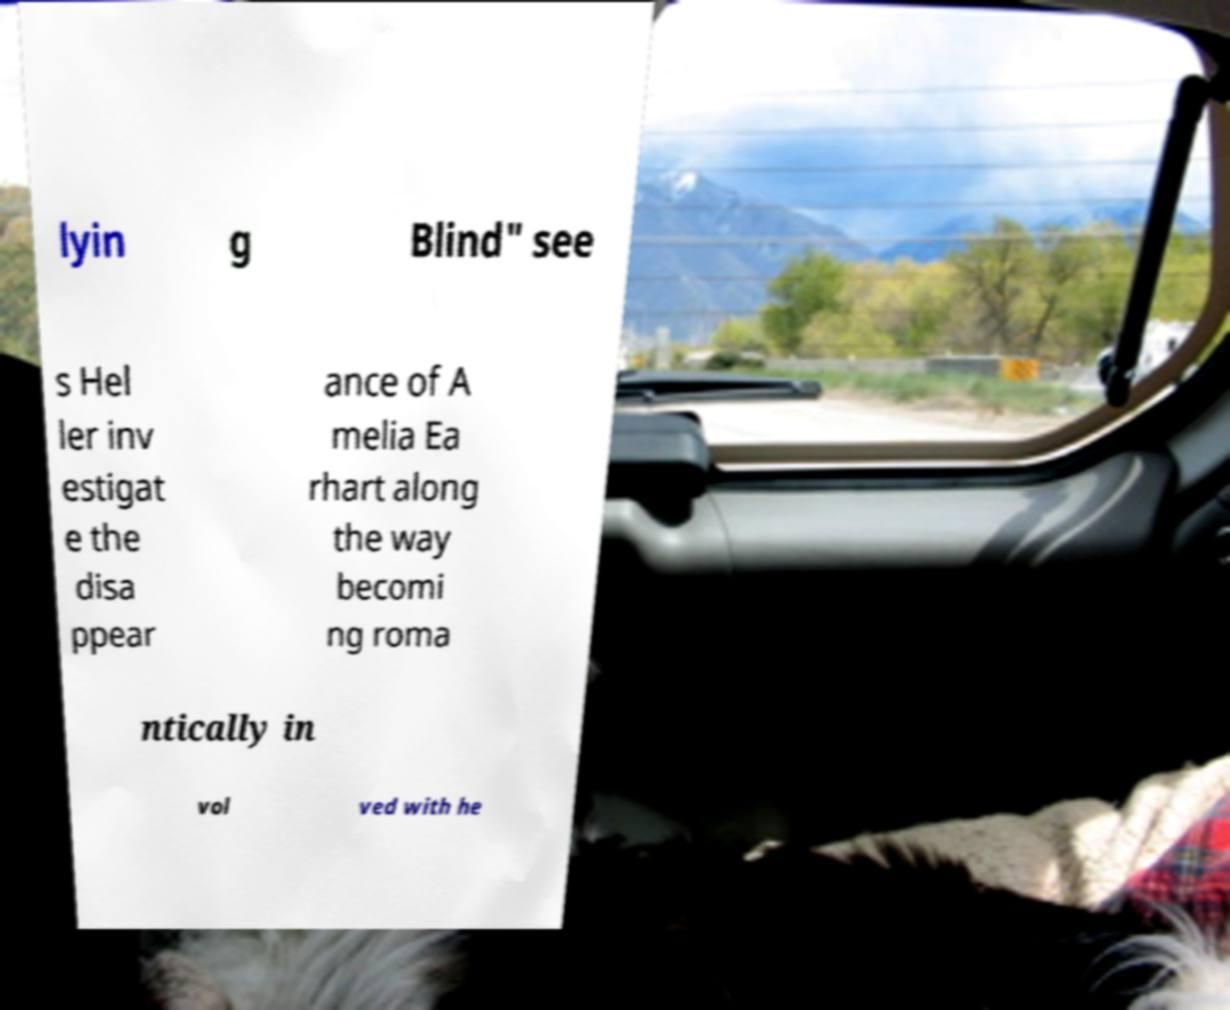Please identify and transcribe the text found in this image. lyin g Blind" see s Hel ler inv estigat e the disa ppear ance of A melia Ea rhart along the way becomi ng roma ntically in vol ved with he 